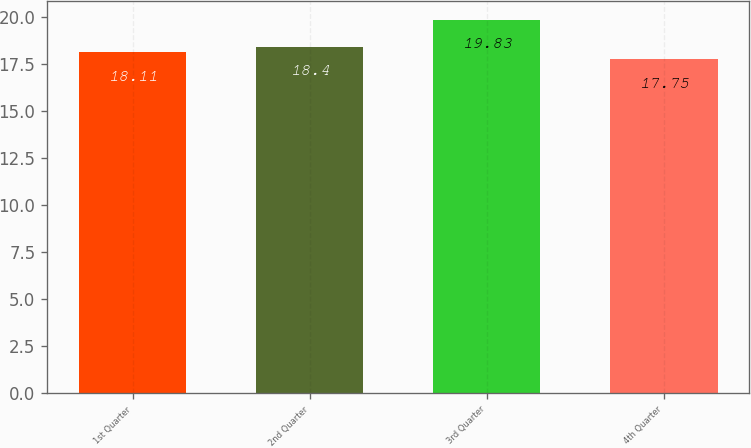Convert chart. <chart><loc_0><loc_0><loc_500><loc_500><bar_chart><fcel>1st Quarter<fcel>2nd Quarter<fcel>3rd Quarter<fcel>4th Quarter<nl><fcel>18.11<fcel>18.4<fcel>19.83<fcel>17.75<nl></chart> 